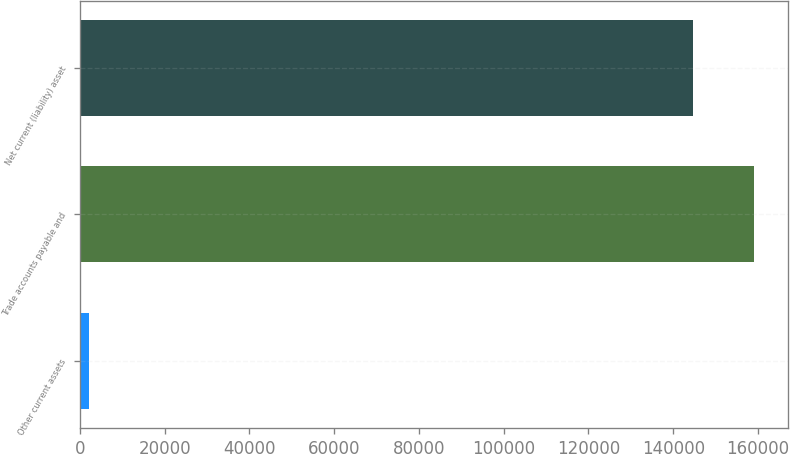<chart> <loc_0><loc_0><loc_500><loc_500><bar_chart><fcel>Other current assets<fcel>Trade accounts payable and<fcel>Net current (liability) asset<nl><fcel>2165<fcel>159044<fcel>144585<nl></chart> 